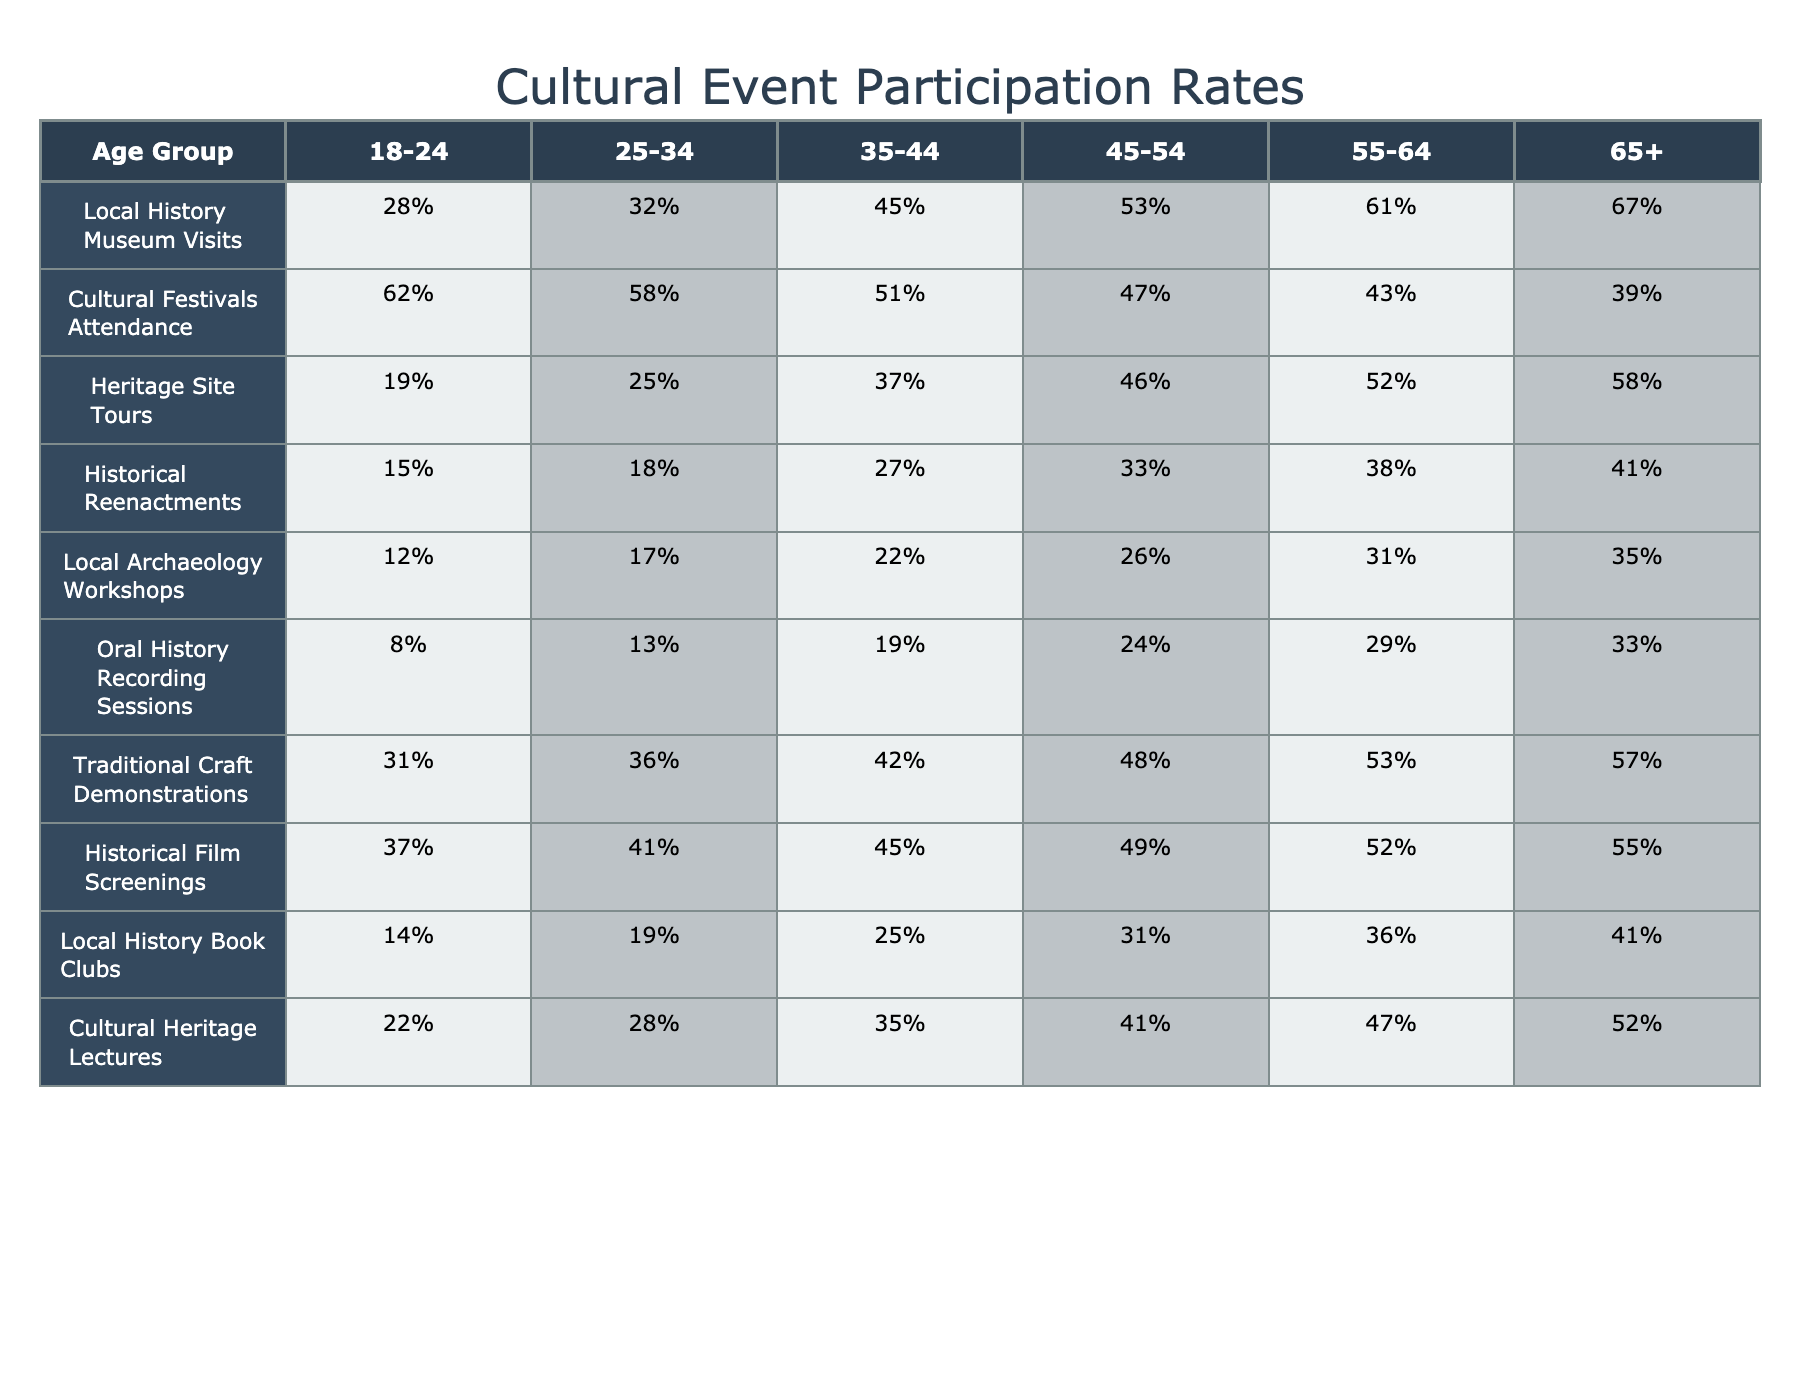What is the participation rate for Local History Museum Visits among those aged 65 and older? From the table, for the age group 65+, the Local History Museum Visits participation rate is listed as 67%.
Answer: 67% Which age group has the highest attendance at Cultural Festivals? Looking at the Cultural Festivals Attendance row in the table, the age group 18-24 has the highest attendance rate at 62%.
Answer: 18-24 What is the difference in participation rates for Historical Film Screenings between the 18-24 and 65+ age groups? The participation rate for Historical Film Screenings for the 18-24 age group is 37%, and for 65+, it's 55%. The difference is 55% - 37% = 18%.
Answer: 18% Is the participation rate for Oral History Recording Sessions higher in the 25-34 age group compared to the 18-24 age group? For the 25-34 age group, the participation rate is 13% while for the 18-24 age group it is 8%. Since 13% is greater than 8%, the answer is yes.
Answer: Yes What is the total participation rate for the 45-54 age group across all cultural events listed? To find the total participation rate, sum the rates for the 45-54 age group: 53% (museum visits) + 47% (festivals) + 46% (heritage site tours) + 33% (reenactments) + 26% (workshops) + 24% (oral history) + 48% (craft demos) + 49% (film screenings) + 31% (book clubs) + 41% (lectures) = 426%. The total participation rate is thus 426%.
Answer: 426% Among all age groups, which cultural event has the lowest participation rate, and what is that rate? The table shows that the lowest participation rate across all age groups is for Oral History Recording Sessions, with a maximum of 33% in the 65+ age group.
Answer: 33% 